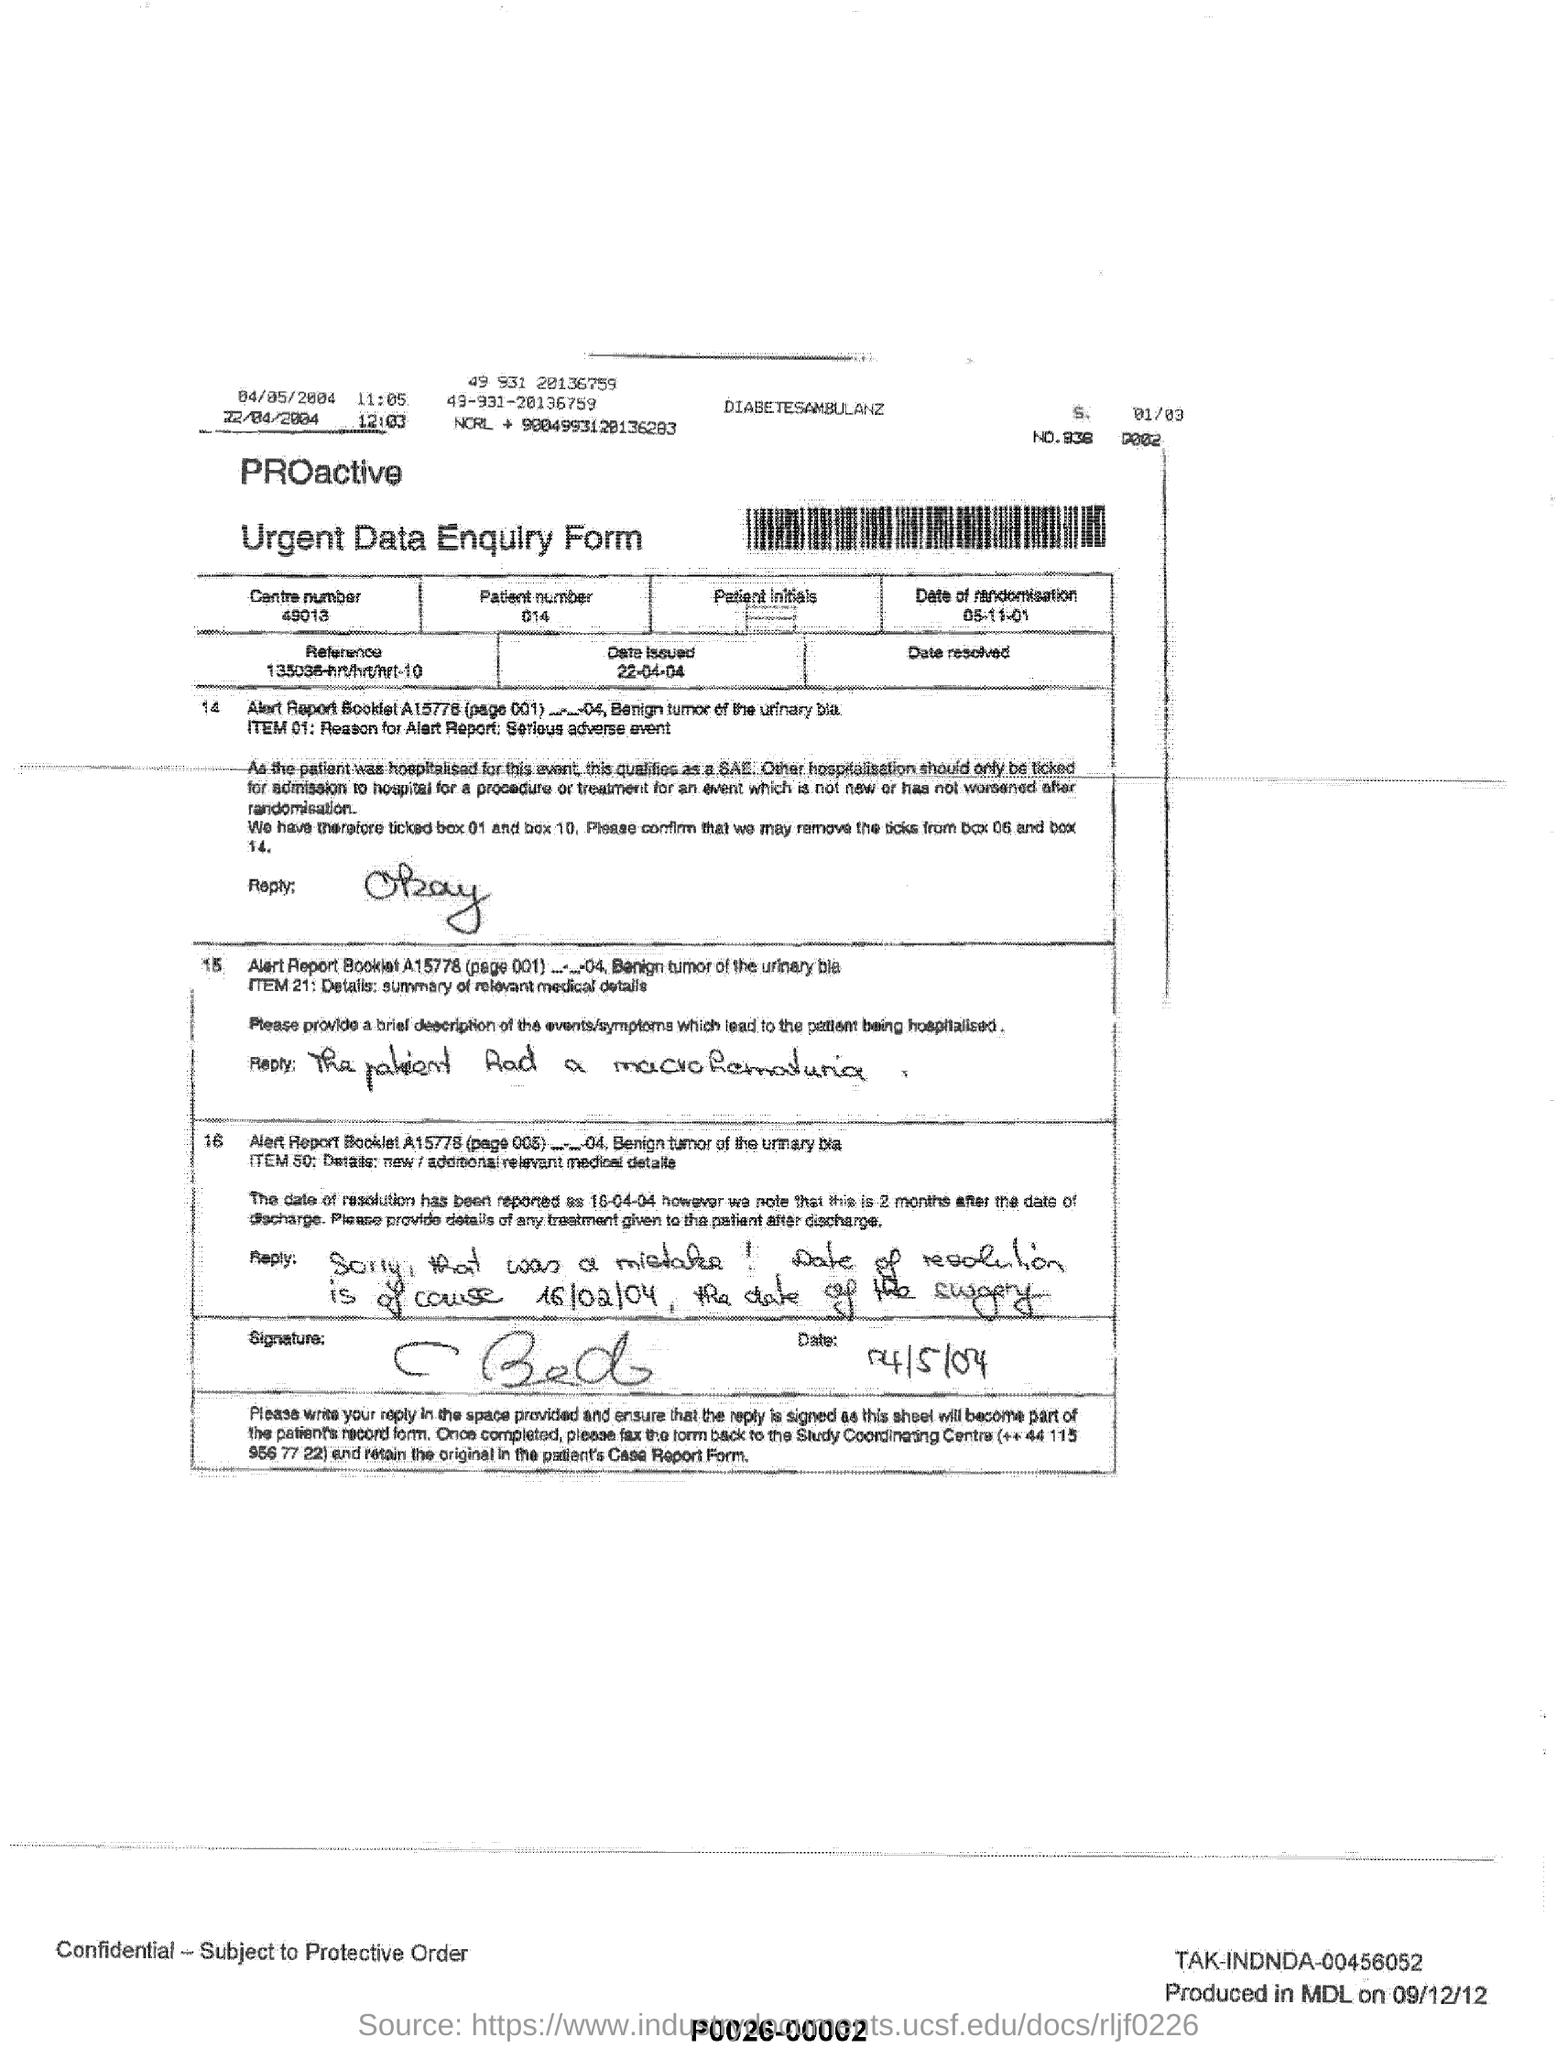Identify some key points in this picture. The center number is 49013. The date mentioned in the form is 22 April 2004 The form's name is 'URGENT DATA ENQUIRY'. The patient number is 014. 